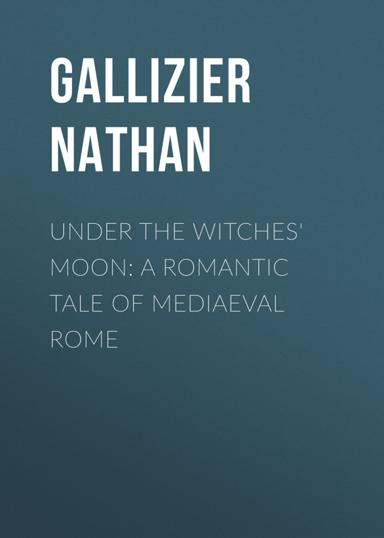What kind of reader would enjoy "Under the Witches' Moon"? This book would captivate readers who are fond of historical romances that weave together elements of magic and mysticism. Fans of narratives that blend factual historical settings with fantastical plots will find "Under the Witches' Moon" particularly appealing. Its rich setting of medieval Rome adds depth that history enthusiasts would also appreciate, making it a well-rounded choice for those who relish in a tale spun across time and mythology. 